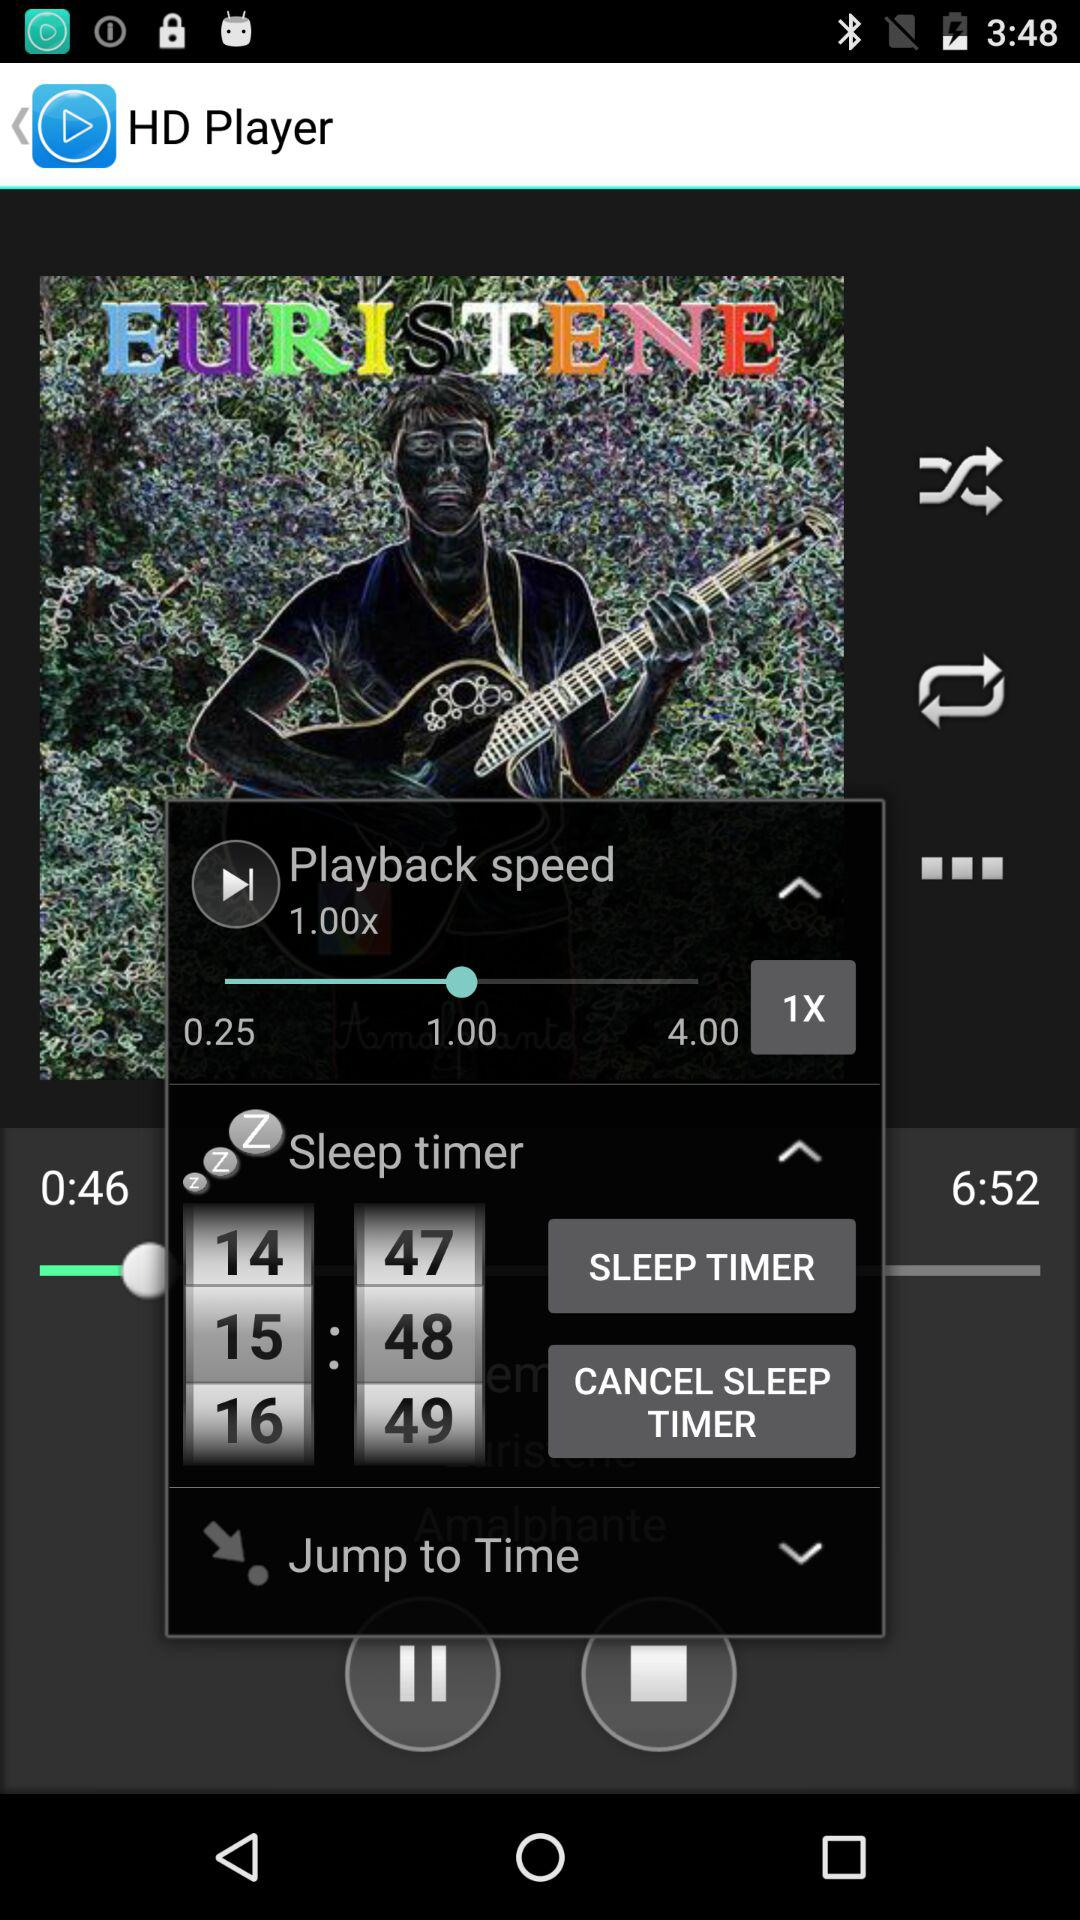How big is the media file?
When the provided information is insufficient, respond with <no answer>. <no answer> 